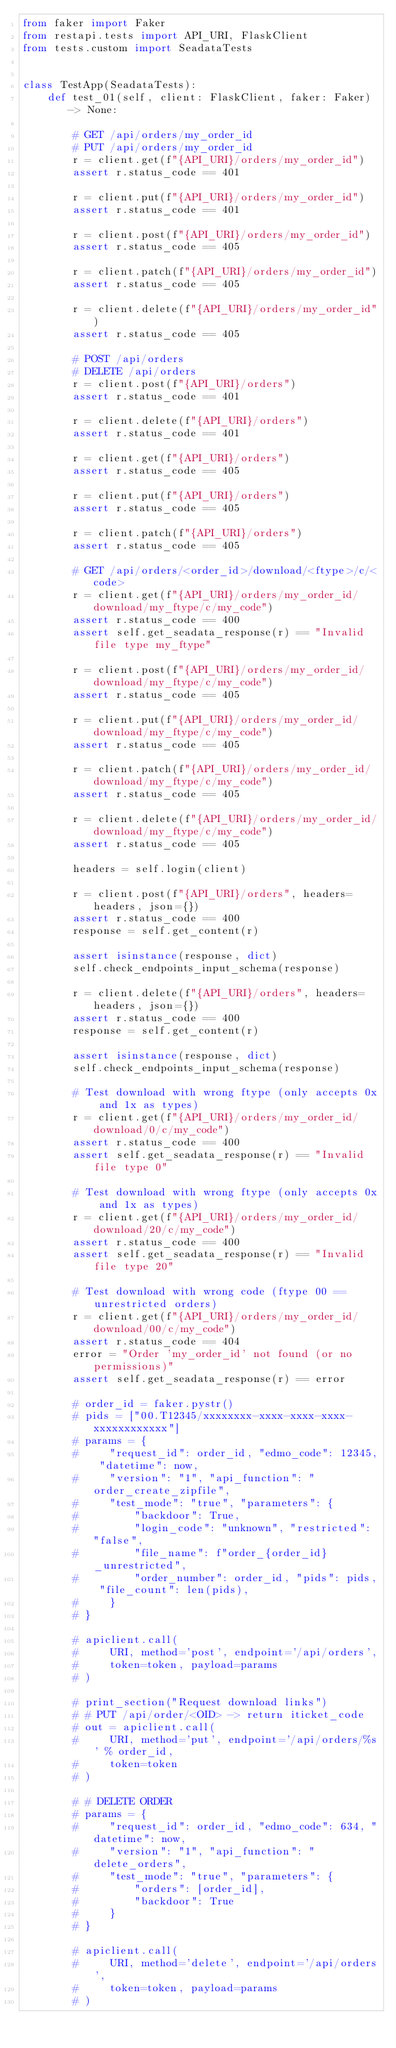Convert code to text. <code><loc_0><loc_0><loc_500><loc_500><_Python_>from faker import Faker
from restapi.tests import API_URI, FlaskClient
from tests.custom import SeadataTests


class TestApp(SeadataTests):
    def test_01(self, client: FlaskClient, faker: Faker) -> None:

        # GET /api/orders/my_order_id
        # PUT /api/orders/my_order_id
        r = client.get(f"{API_URI}/orders/my_order_id")
        assert r.status_code == 401

        r = client.put(f"{API_URI}/orders/my_order_id")
        assert r.status_code == 401

        r = client.post(f"{API_URI}/orders/my_order_id")
        assert r.status_code == 405

        r = client.patch(f"{API_URI}/orders/my_order_id")
        assert r.status_code == 405

        r = client.delete(f"{API_URI}/orders/my_order_id")
        assert r.status_code == 405

        # POST /api/orders
        # DELETE /api/orders
        r = client.post(f"{API_URI}/orders")
        assert r.status_code == 401

        r = client.delete(f"{API_URI}/orders")
        assert r.status_code == 401

        r = client.get(f"{API_URI}/orders")
        assert r.status_code == 405

        r = client.put(f"{API_URI}/orders")
        assert r.status_code == 405

        r = client.patch(f"{API_URI}/orders")
        assert r.status_code == 405

        # GET /api/orders/<order_id>/download/<ftype>/c/<code>
        r = client.get(f"{API_URI}/orders/my_order_id/download/my_ftype/c/my_code")
        assert r.status_code == 400
        assert self.get_seadata_response(r) == "Invalid file type my_ftype"

        r = client.post(f"{API_URI}/orders/my_order_id/download/my_ftype/c/my_code")
        assert r.status_code == 405

        r = client.put(f"{API_URI}/orders/my_order_id/download/my_ftype/c/my_code")
        assert r.status_code == 405

        r = client.patch(f"{API_URI}/orders/my_order_id/download/my_ftype/c/my_code")
        assert r.status_code == 405

        r = client.delete(f"{API_URI}/orders/my_order_id/download/my_ftype/c/my_code")
        assert r.status_code == 405

        headers = self.login(client)

        r = client.post(f"{API_URI}/orders", headers=headers, json={})
        assert r.status_code == 400
        response = self.get_content(r)

        assert isinstance(response, dict)
        self.check_endpoints_input_schema(response)

        r = client.delete(f"{API_URI}/orders", headers=headers, json={})
        assert r.status_code == 400
        response = self.get_content(r)

        assert isinstance(response, dict)
        self.check_endpoints_input_schema(response)

        # Test download with wrong ftype (only accepts 0x and 1x as types)
        r = client.get(f"{API_URI}/orders/my_order_id/download/0/c/my_code")
        assert r.status_code == 400
        assert self.get_seadata_response(r) == "Invalid file type 0"

        # Test download with wrong ftype (only accepts 0x and 1x as types)
        r = client.get(f"{API_URI}/orders/my_order_id/download/20/c/my_code")
        assert r.status_code == 400
        assert self.get_seadata_response(r) == "Invalid file type 20"

        # Test download with wrong code (ftype 00 == unrestricted orders)
        r = client.get(f"{API_URI}/orders/my_order_id/download/00/c/my_code")
        assert r.status_code == 404
        error = "Order 'my_order_id' not found (or no permissions)"
        assert self.get_seadata_response(r) == error

        # order_id = faker.pystr()
        # pids = ["00.T12345/xxxxxxxx-xxxx-xxxx-xxxx-xxxxxxxxxxxx"]
        # params = {
        #     "request_id": order_id, "edmo_code": 12345, "datetime": now,
        #     "version": "1", "api_function": "order_create_zipfile",
        #     "test_mode": "true", "parameters": {
        #         "backdoor": True,
        #         "login_code": "unknown", "restricted": "false",
        #         "file_name": f"order_{order_id}_unrestricted",
        #         "order_number": order_id, "pids": pids, "file_count": len(pids),
        #     }
        # }

        # apiclient.call(
        #     URI, method='post', endpoint='/api/orders',
        #     token=token, payload=params
        # )

        # print_section("Request download links")
        # # PUT /api/order/<OID> -> return iticket_code
        # out = apiclient.call(
        #     URI, method='put', endpoint='/api/orders/%s' % order_id,
        #     token=token
        # )

        # # DELETE ORDER
        # params = {
        #     "request_id": order_id, "edmo_code": 634, "datetime": now,
        #     "version": "1", "api_function": "delete_orders",
        #     "test_mode": "true", "parameters": {
        #         "orders": [order_id],
        #         "backdoor": True
        #     }
        # }

        # apiclient.call(
        #     URI, method='delete', endpoint='/api/orders',
        #     token=token, payload=params
        # )
</code> 